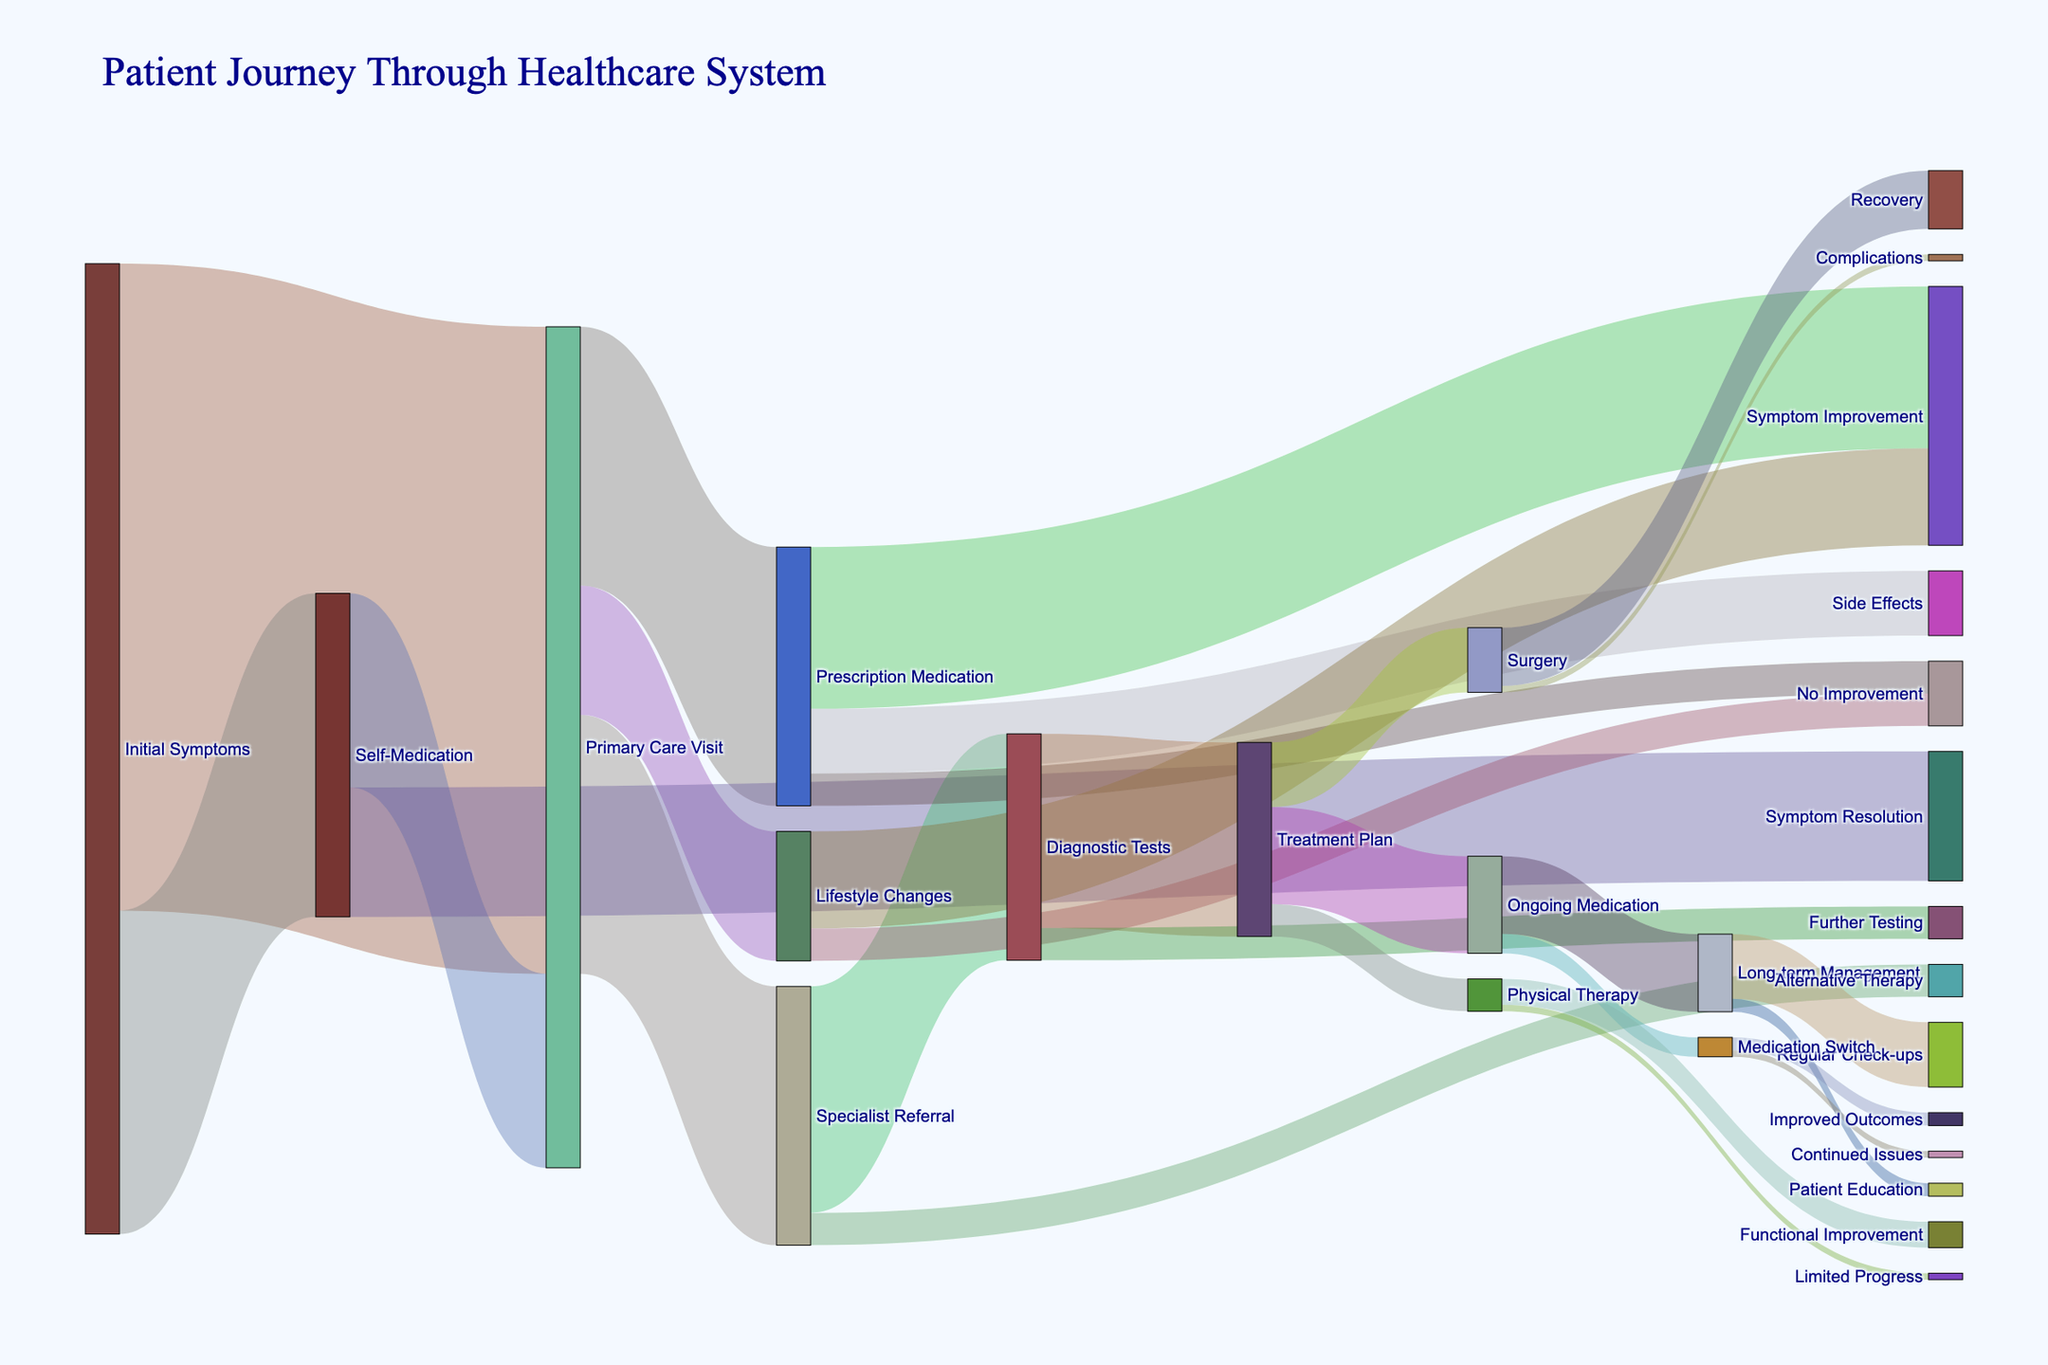Which stage has the highest number of initial entries? To determine which stage has the highest number of initial entries, we look for the source node with the highest value. Here, "Initial Symptoms" leading to "Primary Care Visit" has the highest value of 1000.
Answer: Primary Care Visit What proportion of patients with initial symptoms use self-medication? The proportion is calculated by dividing the number of patients who use self-medication by the total number of patients with initial symptoms. Here, it is 500 (Self-Medication) out of 1500 (Initial Symptoms), so 500/1500 = 1/3 or approximately 33.33%.
Answer: 33.33% How many patient pathways lead to symptom improvement? We need to count all the paths that lead to "Symptom Improvement". These paths go through "Prescription Medication" (250) and "Lifestyle Changes" (150). Adding these up, we get 250 + 150 = 400.
Answer: 400 Which treatment outcome has the fewest patients? To find the treatment outcome with the fewest patients, we look for the target node with the smallest value. "Continued Issues" from "Medication Switch" has the fewest value of 10.
Answer: Continued Issues Are there more patients undergoing surgery or ongoing medication following a treatment plan? By comparing the values, we see that ongoing medication (150) has more patients than surgery (100) following a treatment plan.
Answer: Ongoing Medication What is the total number of patients receiving long-term management? The total is obtained by summing the patients receiving ongoing medication that leads to long-term management. "Long-term Management" has 120 from "Ongoing Medication".
Answer: 120 How frequently do initial symptoms result in a specialist referral directly or indirectly? To find this, add up the patients going to a specialist directly (400 from Primary Care Visit) and indirectly (300 from Self-Medication leading to Primary Care Visit). Therefore, 400 + 0 (if there was any other further divide) = 700.
Answer: 700 What is the sum of patients experiencing no improvement from both lifestyle changes and prescription medication? Sum the values leading to "No Improvement" from "Lifestyle Changes" (50) and "Prescription Medication" (50). Adding them together gives 50 + 50 = 100.
Answer: 100 Is the number of patients who experience recovery post-surgery greater than those who experience complications? To determine this, compare the values. Post-surgery recovery has a value of 90, while complications have a value of 10. Therefore, recovery is greater than complications.
Answer: Yes 